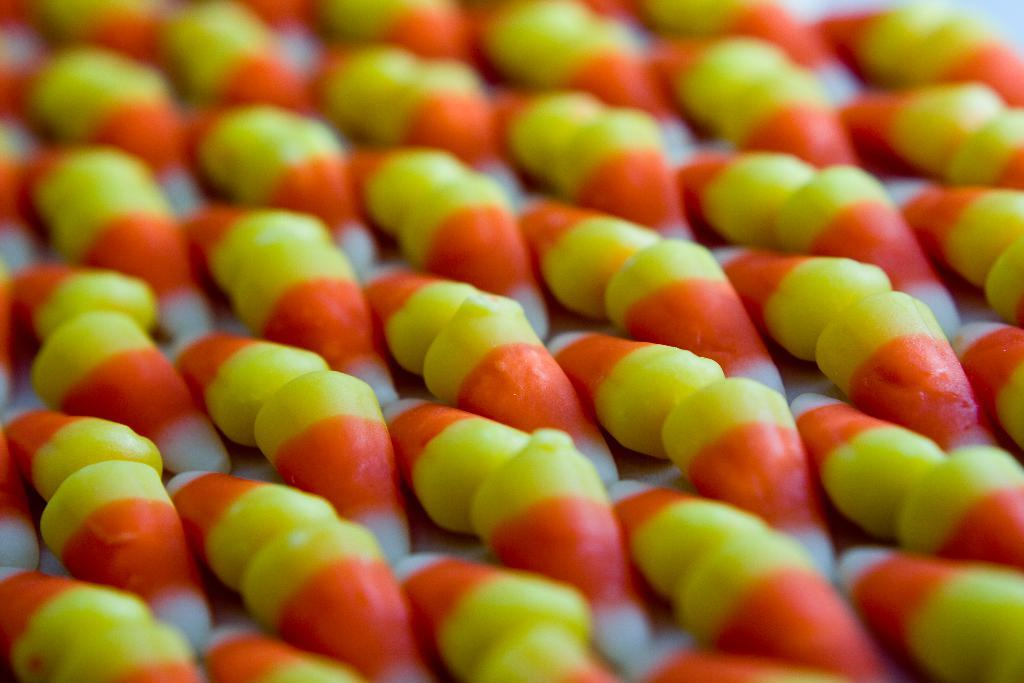What type of objects can be seen in the image? There are colorful candies in the image. Can you describe the appearance of the candies? The candies are colorful, which suggests they come in various shades and hues. What might be the purpose of these candies? The candies are likely meant for consumption, possibly as a sweet treat or dessert. Is there a lamp illuminating the candies in the image? There is no mention of a lamp in the provided facts, and therefore it cannot be determined if there is a lamp present in the image. 